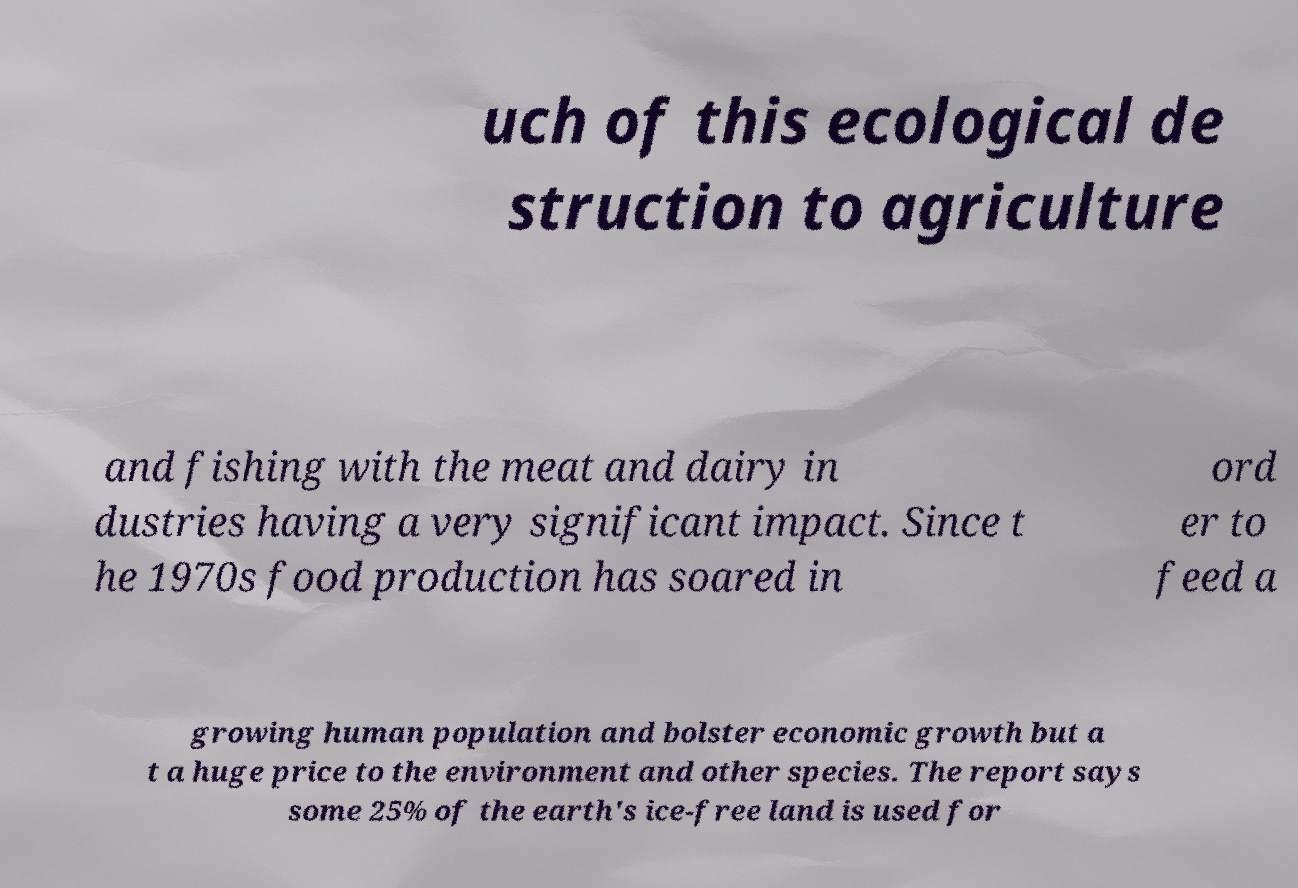I need the written content from this picture converted into text. Can you do that? uch of this ecological de struction to agriculture and fishing with the meat and dairy in dustries having a very significant impact. Since t he 1970s food production has soared in ord er to feed a growing human population and bolster economic growth but a t a huge price to the environment and other species. The report says some 25% of the earth's ice-free land is used for 